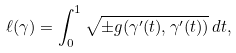Convert formula to latex. <formula><loc_0><loc_0><loc_500><loc_500>\ell ( \gamma ) = \int _ { 0 } ^ { 1 } { \sqrt { \pm g ( \gamma ^ { \prime } ( t ) , \gamma ^ { \prime } ( t ) ) } } \, d t ,</formula> 